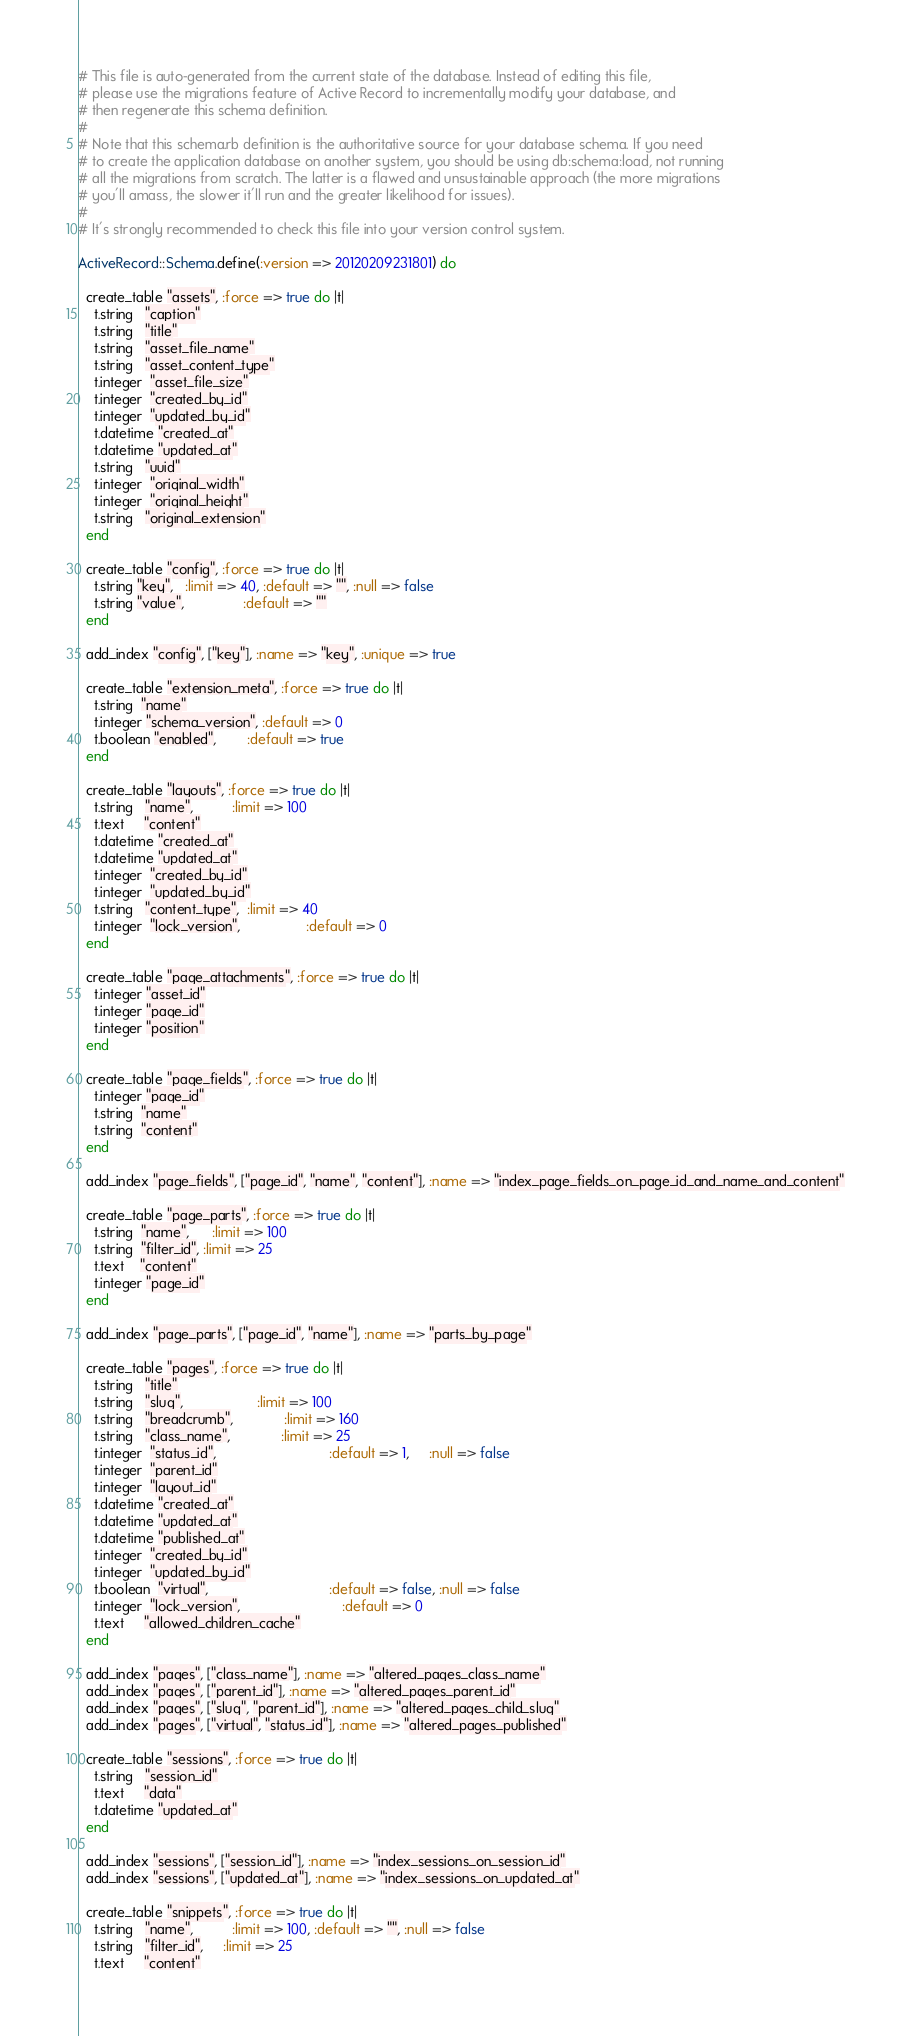Convert code to text. <code><loc_0><loc_0><loc_500><loc_500><_Ruby_># This file is auto-generated from the current state of the database. Instead of editing this file, 
# please use the migrations feature of Active Record to incrementally modify your database, and
# then regenerate this schema definition.
#
# Note that this schema.rb definition is the authoritative source for your database schema. If you need
# to create the application database on another system, you should be using db:schema:load, not running
# all the migrations from scratch. The latter is a flawed and unsustainable approach (the more migrations
# you'll amass, the slower it'll run and the greater likelihood for issues).
#
# It's strongly recommended to check this file into your version control system.

ActiveRecord::Schema.define(:version => 20120209231801) do

  create_table "assets", :force => true do |t|
    t.string   "caption"
    t.string   "title"
    t.string   "asset_file_name"
    t.string   "asset_content_type"
    t.integer  "asset_file_size"
    t.integer  "created_by_id"
    t.integer  "updated_by_id"
    t.datetime "created_at"
    t.datetime "updated_at"
    t.string   "uuid"
    t.integer  "original_width"
    t.integer  "original_height"
    t.string   "original_extension"
  end

  create_table "config", :force => true do |t|
    t.string "key",   :limit => 40, :default => "", :null => false
    t.string "value",               :default => ""
  end

  add_index "config", ["key"], :name => "key", :unique => true

  create_table "extension_meta", :force => true do |t|
    t.string  "name"
    t.integer "schema_version", :default => 0
    t.boolean "enabled",        :default => true
  end

  create_table "layouts", :force => true do |t|
    t.string   "name",          :limit => 100
    t.text     "content"
    t.datetime "created_at"
    t.datetime "updated_at"
    t.integer  "created_by_id"
    t.integer  "updated_by_id"
    t.string   "content_type",  :limit => 40
    t.integer  "lock_version",                 :default => 0
  end

  create_table "page_attachments", :force => true do |t|
    t.integer "asset_id"
    t.integer "page_id"
    t.integer "position"
  end

  create_table "page_fields", :force => true do |t|
    t.integer "page_id"
    t.string  "name"
    t.string  "content"
  end

  add_index "page_fields", ["page_id", "name", "content"], :name => "index_page_fields_on_page_id_and_name_and_content"

  create_table "page_parts", :force => true do |t|
    t.string  "name",      :limit => 100
    t.string  "filter_id", :limit => 25
    t.text    "content"
    t.integer "page_id"
  end

  add_index "page_parts", ["page_id", "name"], :name => "parts_by_page"

  create_table "pages", :force => true do |t|
    t.string   "title"
    t.string   "slug",                   :limit => 100
    t.string   "breadcrumb",             :limit => 160
    t.string   "class_name",             :limit => 25
    t.integer  "status_id",                             :default => 1,     :null => false
    t.integer  "parent_id"
    t.integer  "layout_id"
    t.datetime "created_at"
    t.datetime "updated_at"
    t.datetime "published_at"
    t.integer  "created_by_id"
    t.integer  "updated_by_id"
    t.boolean  "virtual",                               :default => false, :null => false
    t.integer  "lock_version",                          :default => 0
    t.text     "allowed_children_cache"
  end

  add_index "pages", ["class_name"], :name => "altered_pages_class_name"
  add_index "pages", ["parent_id"], :name => "altered_pages_parent_id"
  add_index "pages", ["slug", "parent_id"], :name => "altered_pages_child_slug"
  add_index "pages", ["virtual", "status_id"], :name => "altered_pages_published"

  create_table "sessions", :force => true do |t|
    t.string   "session_id"
    t.text     "data"
    t.datetime "updated_at"
  end

  add_index "sessions", ["session_id"], :name => "index_sessions_on_session_id"
  add_index "sessions", ["updated_at"], :name => "index_sessions_on_updated_at"

  create_table "snippets", :force => true do |t|
    t.string   "name",          :limit => 100, :default => "", :null => false
    t.string   "filter_id",     :limit => 25
    t.text     "content"</code> 